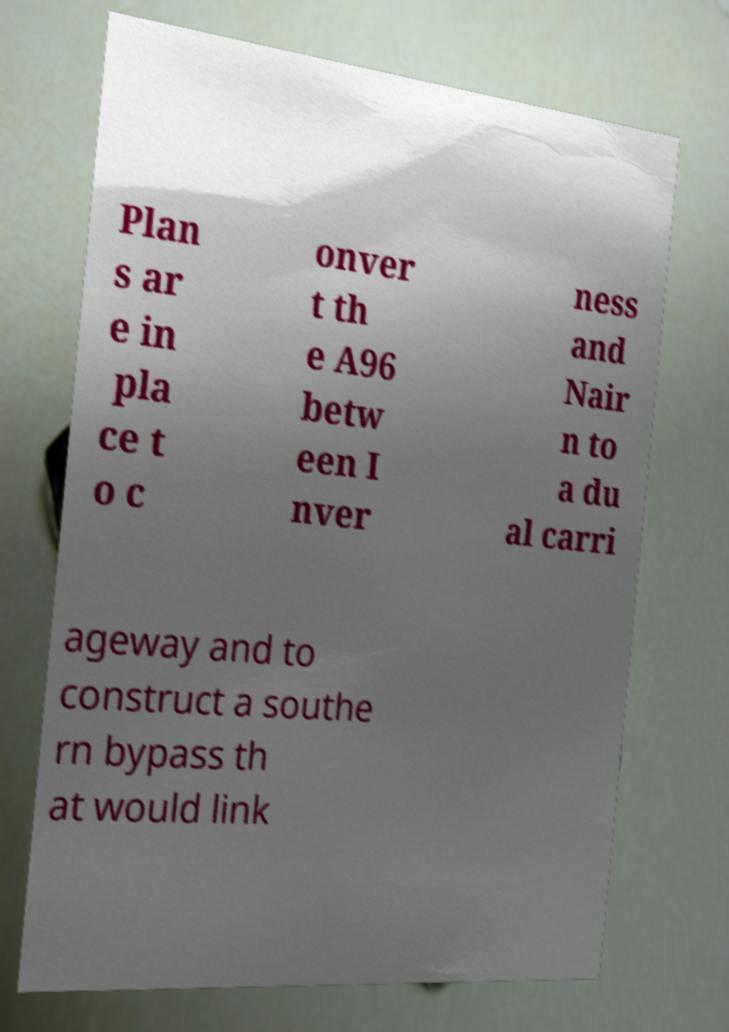Please identify and transcribe the text found in this image. Plan s ar e in pla ce t o c onver t th e A96 betw een I nver ness and Nair n to a du al carri ageway and to construct a southe rn bypass th at would link 